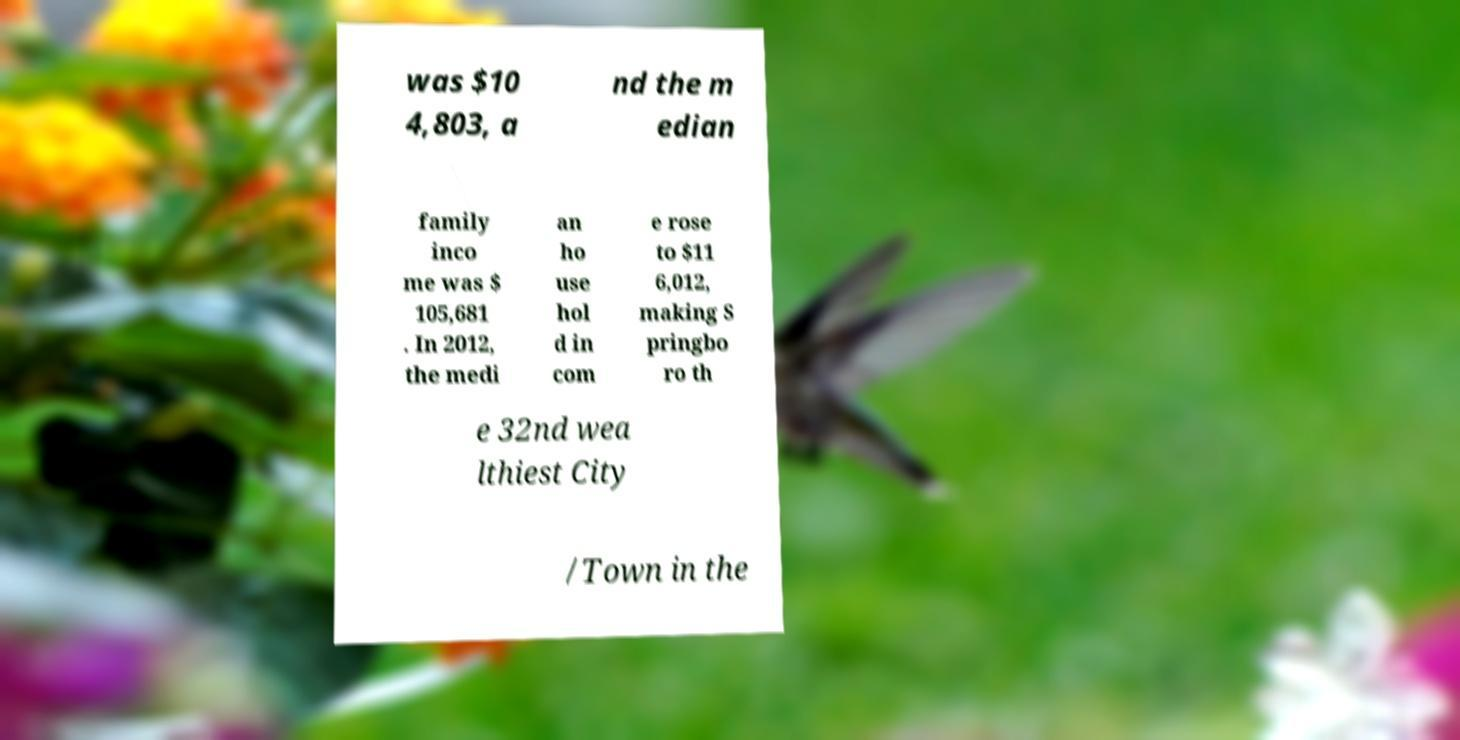Can you read and provide the text displayed in the image?This photo seems to have some interesting text. Can you extract and type it out for me? was $10 4,803, a nd the m edian family inco me was $ 105,681 . In 2012, the medi an ho use hol d in com e rose to $11 6,012, making S pringbo ro th e 32nd wea lthiest City /Town in the 